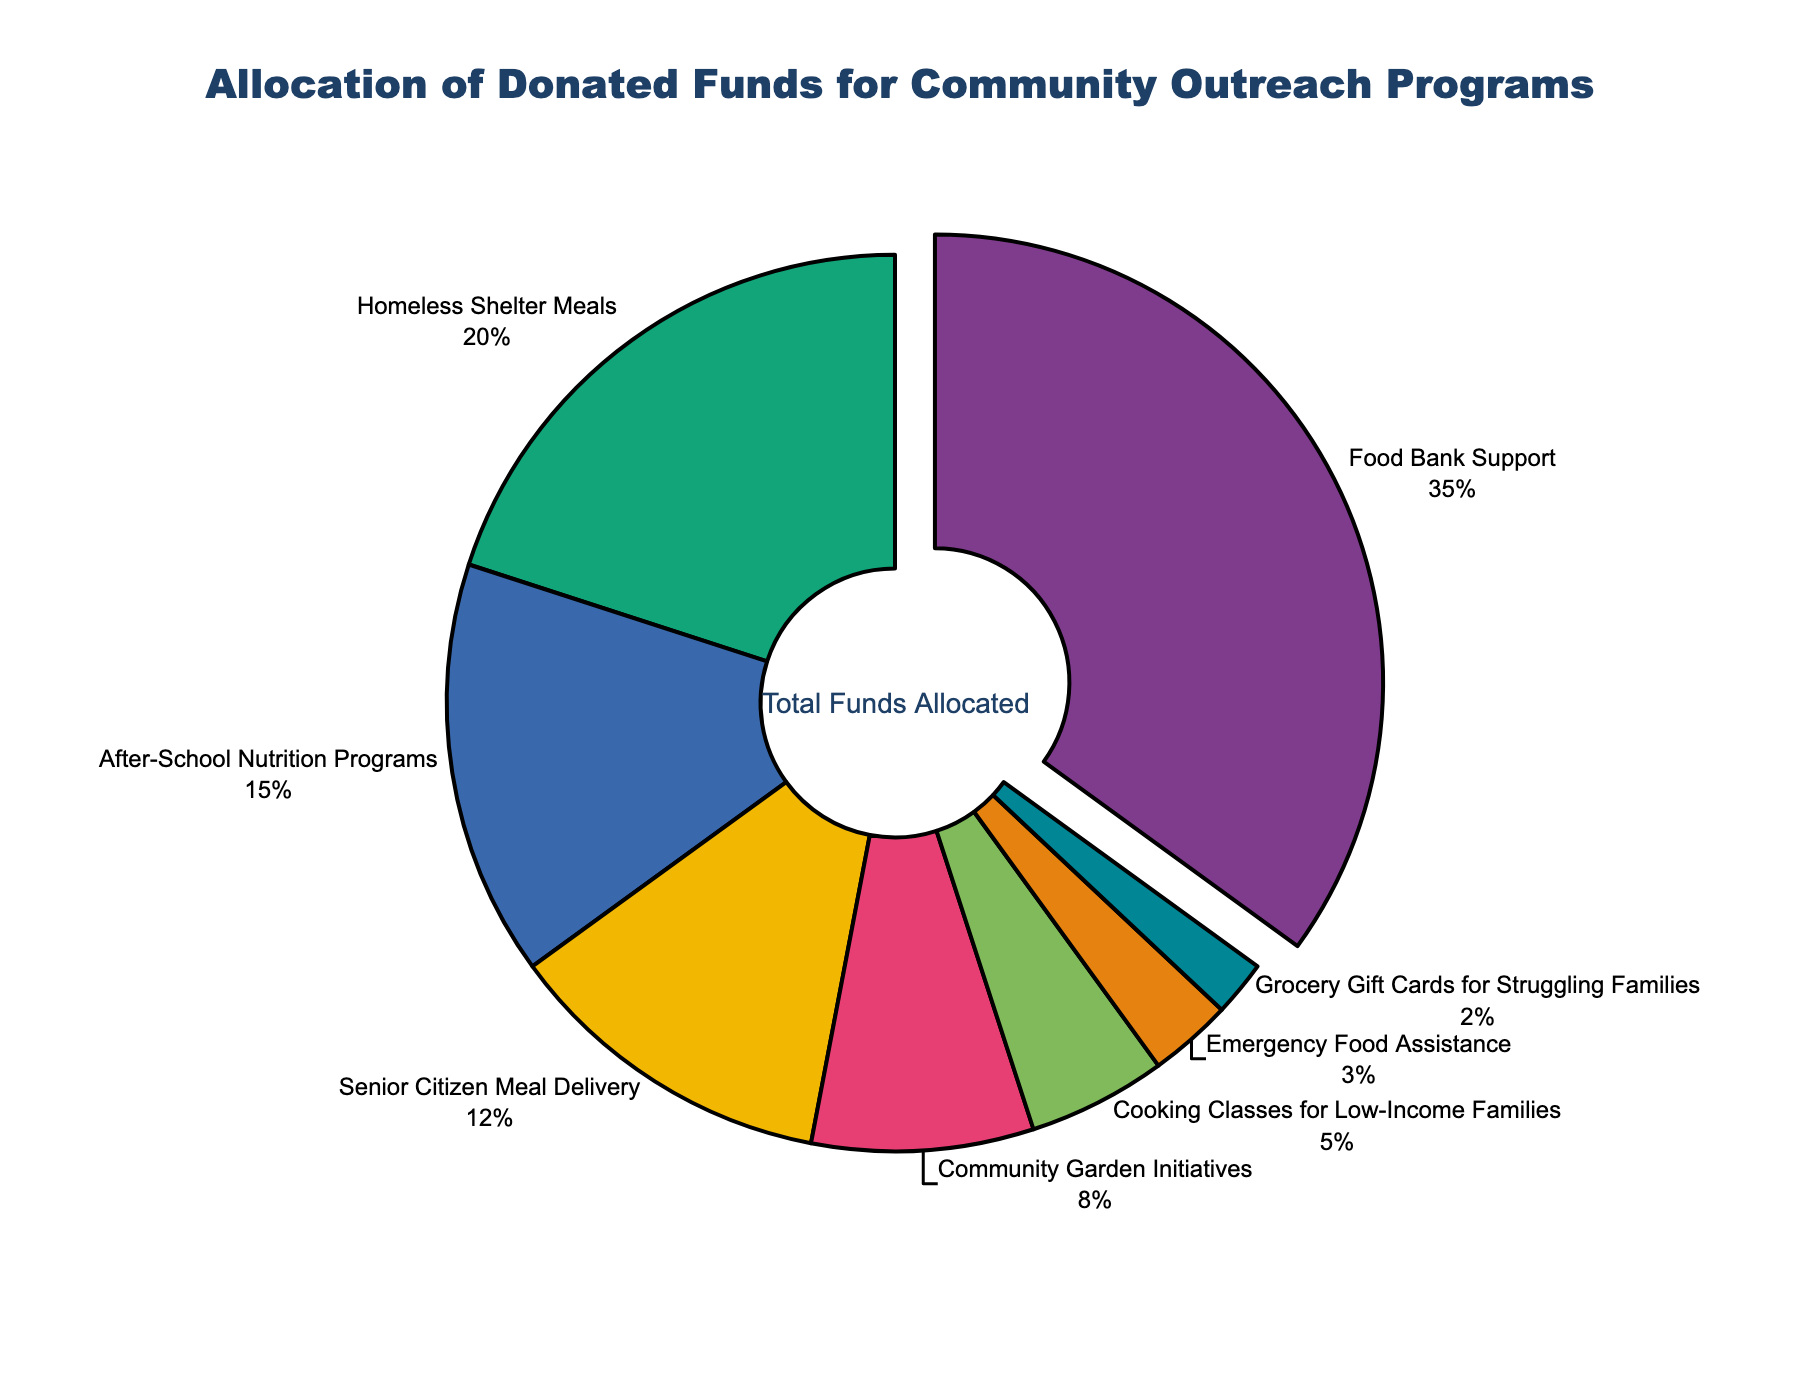What program receives the highest percentage of donated funds? The segment that is pulled out slightly is labeled "Food Bank Support" and shows a percentage of 35%.
Answer: Food Bank Support Which program receives less funding, Community Garden Initiatives or After-School Nutrition Programs? Community Garden Initiatives receives 8% while After-School Nutrition Programs get 15%.
Answer: Community Garden Initiatives What's the total percentage allocated to Homeless Shelter Meals and Senior Citizen Meal Delivery combined? Homeless Shelter Meals has 20% and Senior Citizen Meal Delivery has 12%. Adding these together, 20% + 12% = 32%.
Answer: 32% How many programs receive 10% or more of the funds? Food Bank Support (35%), Homeless Shelter Meals (20%), After-School Nutrition Programs (15%), and Senior Citizen Meal Delivery (12%) each receive 10% or more. That's 4 programs.
Answer: 4 Which program receives the least amount of donated funds? The smallest segment is labeled "Grocery Gift Cards for Struggling Families" with 2%.
Answer: Grocery Gift Cards for Struggling Families Is the combined percentage for Emergency Food Assistance and Grocery Gift Cards for Struggling Families more or less than 10%? Emergency Food Assistance has 3% and Grocery Gift Cards for Struggling Families have 2%. Their combined percentage is 3% + 2% = 5%, which is less than 10%.
Answer: Less What is the difference in percentage allocation between After-School Nutrition Programs and Cooking Classes for Low-Income Families? After-School Nutrition Programs receive 15% and Cooking Classes for Low-Income Families receive 5%. The difference is 15% - 5% = 10%.
Answer: 10% List the programs that receive exactly 5% or less of the total funds. Emergency Food Assistance (3%) and Grocery Gift Cards for Struggling Families (2%) receive less than 5%, and Cooking Classes for Low-Income Families receive exactly 5%.
Answer: Emergency Food Assistance, Grocery Gift Cards for Struggling Families, Cooking Classes for Low-Income Families Which two programs when combined have a total percentage close to but not exceeding 40%? Homeless Shelter Meals (20%) + After-School Nutrition Programs (15%) = 35% or After-School Nutrition Programs (15%) + Senior Citizen Meal Delivery (12%) + Community Garden Initiatives (8%) = 35%. Both combinations are close but do not exceed 40%.
Answer: Homeless Shelter Meals, After-School Nutrition Programs; After-School Nutrition Programs, Senior Citizen Meal Delivery, Community Garden Initiatives What percentage of the funds is allocated to programs related to low-income families? Cooking Classes for Low-Income Families receive 5% and Grocery Gift Cards for Struggling Families receive 2%. Adding these, 5% + 2% = 7%.
Answer: 7% 